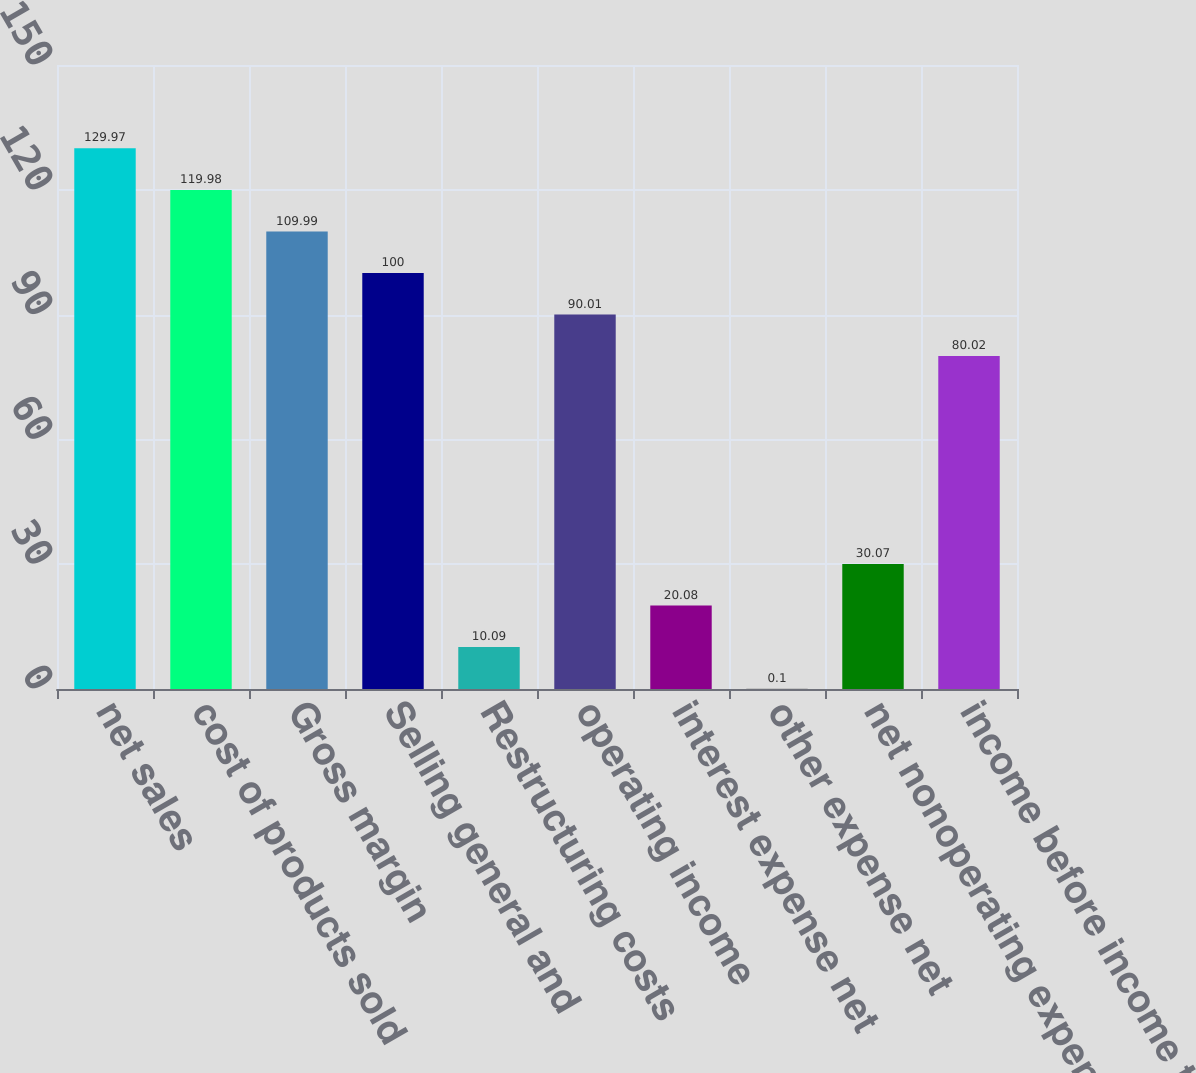Convert chart to OTSL. <chart><loc_0><loc_0><loc_500><loc_500><bar_chart><fcel>net sales<fcel>cost of products sold<fcel>Gross margin<fcel>Selling general and<fcel>Restructuring costs<fcel>operating income<fcel>interest expense net<fcel>other expense net<fcel>net nonoperating expenses<fcel>income before income taxes<nl><fcel>129.97<fcel>119.98<fcel>109.99<fcel>100<fcel>10.09<fcel>90.01<fcel>20.08<fcel>0.1<fcel>30.07<fcel>80.02<nl></chart> 